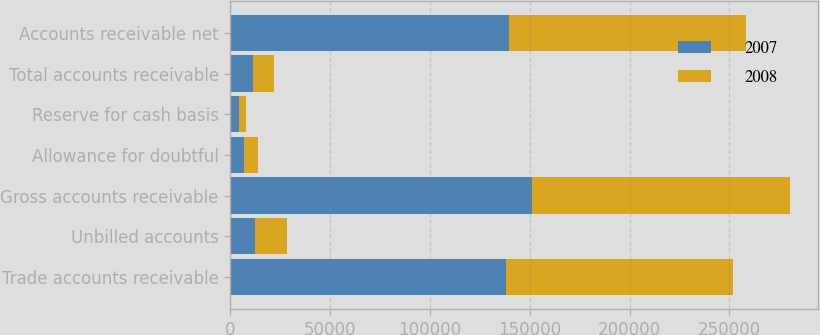Convert chart. <chart><loc_0><loc_0><loc_500><loc_500><stacked_bar_chart><ecel><fcel>Trade accounts receivable<fcel>Unbilled accounts<fcel>Gross accounts receivable<fcel>Allowance for doubtful<fcel>Reserve for cash basis<fcel>Total accounts receivable<fcel>Accounts receivable net<nl><fcel>2007<fcel>138286<fcel>12596<fcel>150882<fcel>6943<fcel>4327<fcel>11270<fcel>139612<nl><fcel>2008<fcel>113357<fcel>15978<fcel>129335<fcel>6878<fcel>3513<fcel>10391<fcel>118944<nl></chart> 